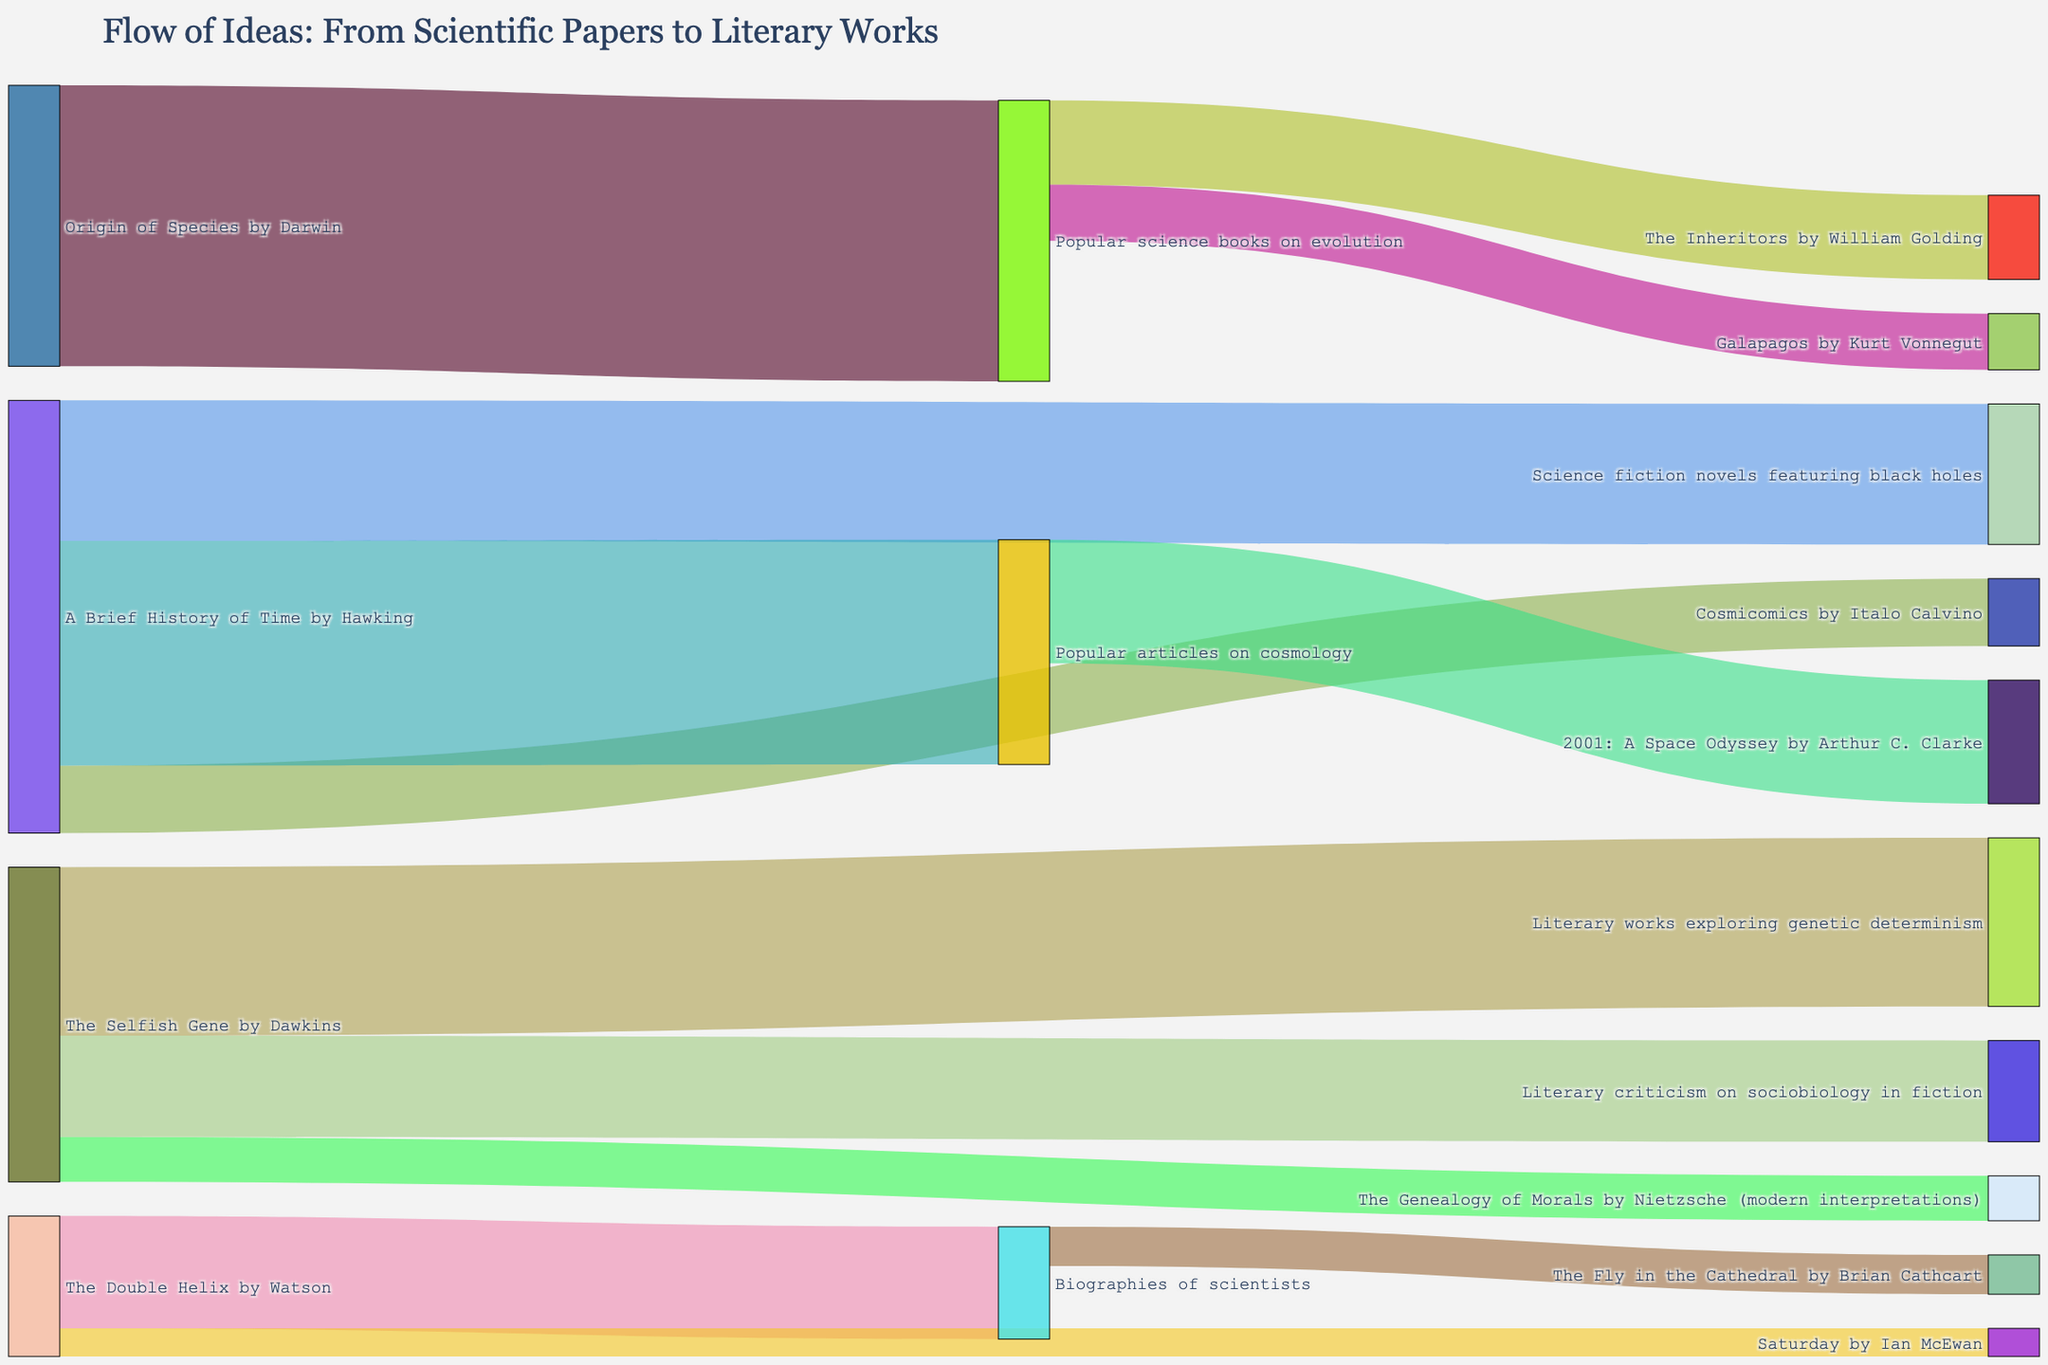What is the title of the Sankey Diagram? The title is found at the top of the Sankey Diagram, directly describing what the figure represents.
Answer: Flow of Ideas: From Scientific Papers to Literary Works Which source has the highest flow to popular articles on cosmology? Identify the link with the highest flow targeting popular articles on cosmology and trace it back to its source.
Answer: "A Brief History of Time" by Hawking How many literary works are influenced by popular science books on evolution? Count all the links originating from popular science books on evolution and connecting to literary works.
Answer: Two What is the total value of ideas originating from "The Selfish Gene" by Dawkins? Add up all the values of the sinks receiving flow from "The Selfish Gene" by Dawkins.
Answer: 56 Which literary work has the highest incoming flow from any single source, regardless of the number of sources? Find the literary work with the highest single incoming flow value from its connections in the diagram.
Answer: "2001: A Space Odyssey" by Arthur C. Clarke Which scientific paper influences the most diverse set of target categories? Count how many different target categories each scientific paper connects to, and compare to see which one has the most.
Answer: "The Selfish Gene" by Dawkins How does the total flow from "Popular science books on evolution" compare to the total flow from "Popular articles on cosmology"? Sum the values of all the links originating from each of these sources and compare the totals.
Answer: Popular articles on cosmology has a higher total flow Which sources contribute to literary criticism on sociobiology in fiction? Identify the nodes directly linked to literary criticism on sociobiology in fiction as sinks.
Answer: "The Selfish Gene" by Dawkins What is the flow value from "The Double Helix" by Watson to "Saturday" by Ian McEwan? Locate the link between these two nodes and note its associated value.
Answer: 5 Which category has the largest total outflow? Sum up the values for each category’s outgoing links and find the maximum total.
Answer: "A Brief History of Time" by Hawking 